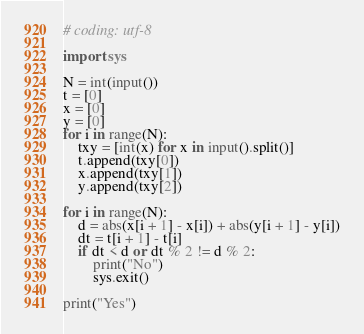Convert code to text. <code><loc_0><loc_0><loc_500><loc_500><_Python_># coding: utf-8

import sys

N = int(input())
t = [0]
x = [0]
y = [0]
for i in range(N):
	txy = [int(x) for x in input().split()]
	t.append(txy[0])
	x.append(txy[1])
	y.append(txy[2])

for i in range(N):
	d = abs(x[i + 1] - x[i]) + abs(y[i + 1] - y[i])
	dt = t[i + 1] - t[i]
	if dt < d or dt % 2 != d % 2:
		print("No")
		sys.exit()
	
print("Yes")</code> 